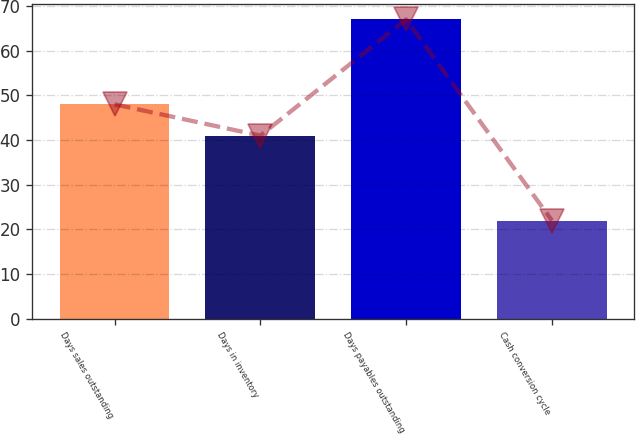<chart> <loc_0><loc_0><loc_500><loc_500><bar_chart><fcel>Days sales outstanding<fcel>Days in inventory<fcel>Days payables outstanding<fcel>Cash conversion cycle<nl><fcel>48<fcel>41<fcel>67<fcel>22<nl></chart> 